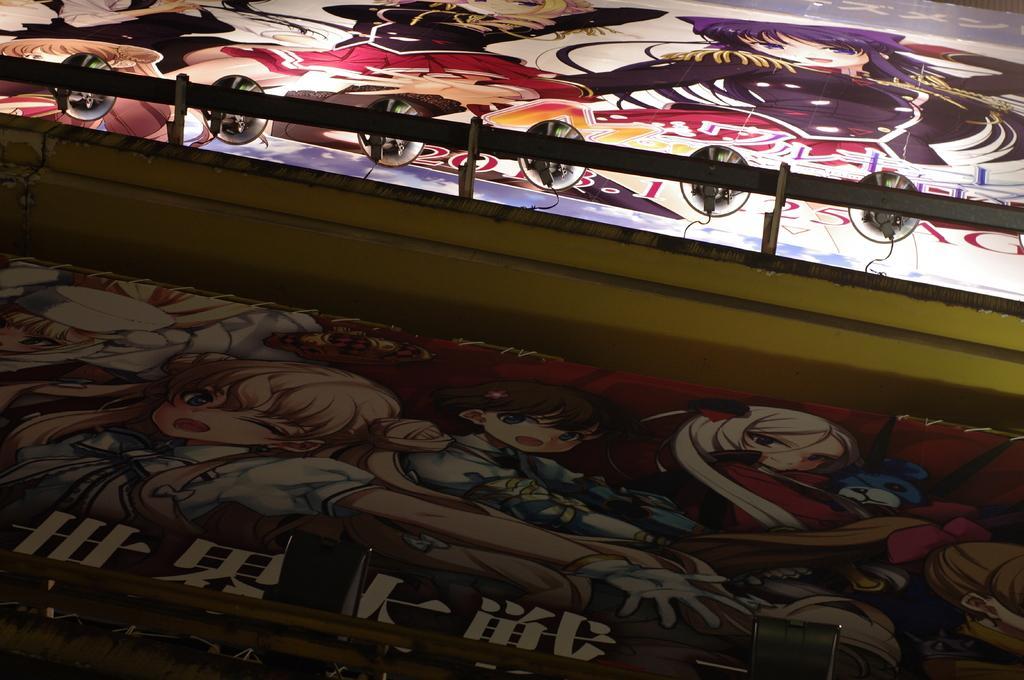Describe this image in one or two sentences. In this image we can see the paintings of cartoon. 